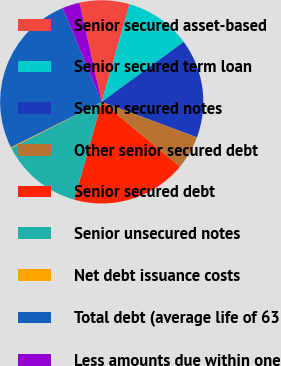<chart> <loc_0><loc_0><loc_500><loc_500><pie_chart><fcel>Senior secured asset-based<fcel>Senior secured term loan<fcel>Senior secured notes<fcel>Other senior secured debt<fcel>Senior secured debt<fcel>Senior unsecured notes<fcel>Net debt issuance costs<fcel>Total debt (average life of 63<fcel>Less amounts due within one<nl><fcel>7.94%<fcel>10.53%<fcel>15.73%<fcel>5.34%<fcel>18.33%<fcel>13.13%<fcel>0.14%<fcel>26.12%<fcel>2.74%<nl></chart> 